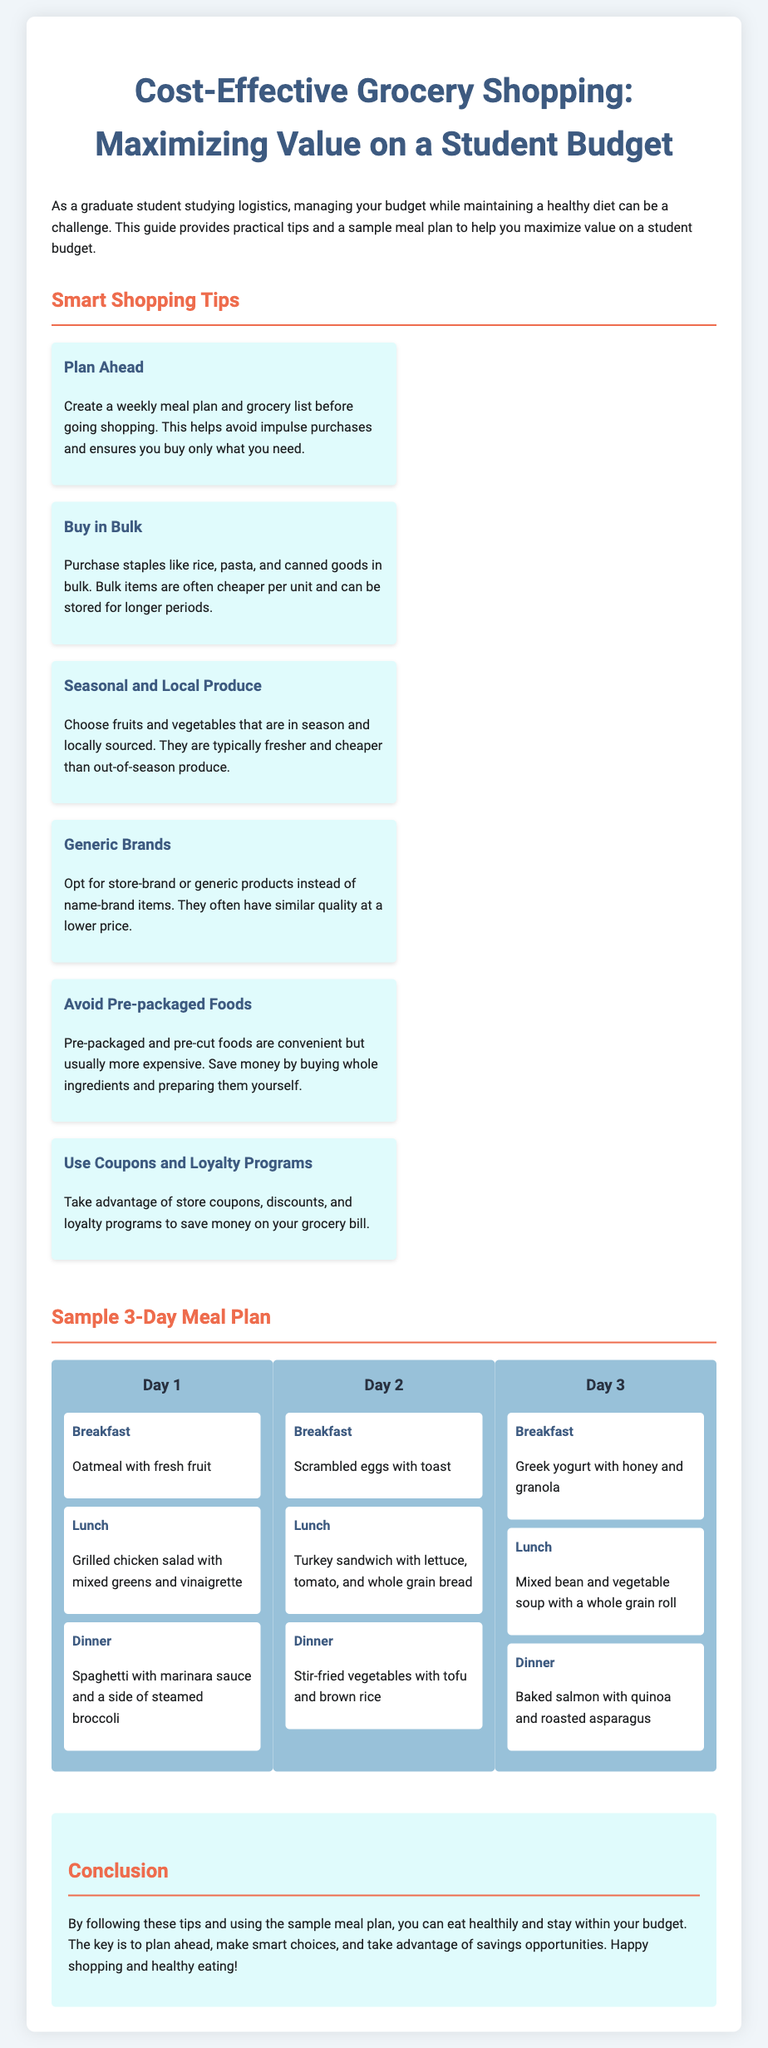What is the title of the document? The title is provided at the beginning of the document, clearly specified in the header.
Answer: Cost-Effective Grocery Shopping: Maximizing Value on a Student Budget How many days does the sample meal plan cover? The document specifies a sample meal plan which includes meals for three days.
Answer: 3 What is suggested for breakfast on Day 2? The document lists specific meals for each day and meal type. On Day 2, breakfast is scrambled eggs with toast.
Answer: Scrambled eggs with toast Which meal includes baked salmon? The document outlines the meals for each day. Baked salmon is included in the dinner of Day 3.
Answer: Dinner on Day 3 What type of products should students opt for to save money? The document suggests students choose generics instead of name brands for cost savings.
Answer: Generic brands Which tip suggests purchasing staples in larger quantities? The tip that encourages buying in bulk highlights the benefits for cost-saving on staples.
Answer: Buy in Bulk What is the purpose of the document? The purpose is summarized in the introductory paragraph that describes the goal of managing budget while maintaining a healthy diet.
Answer: Maximizing value on a student budget What is a food option for lunch on Day 1? The document provides specific meal options for each lunch, which highlights grilled chicken salad for Day 1.
Answer: Grilled chicken salad with mixed greens and vinaigrette 